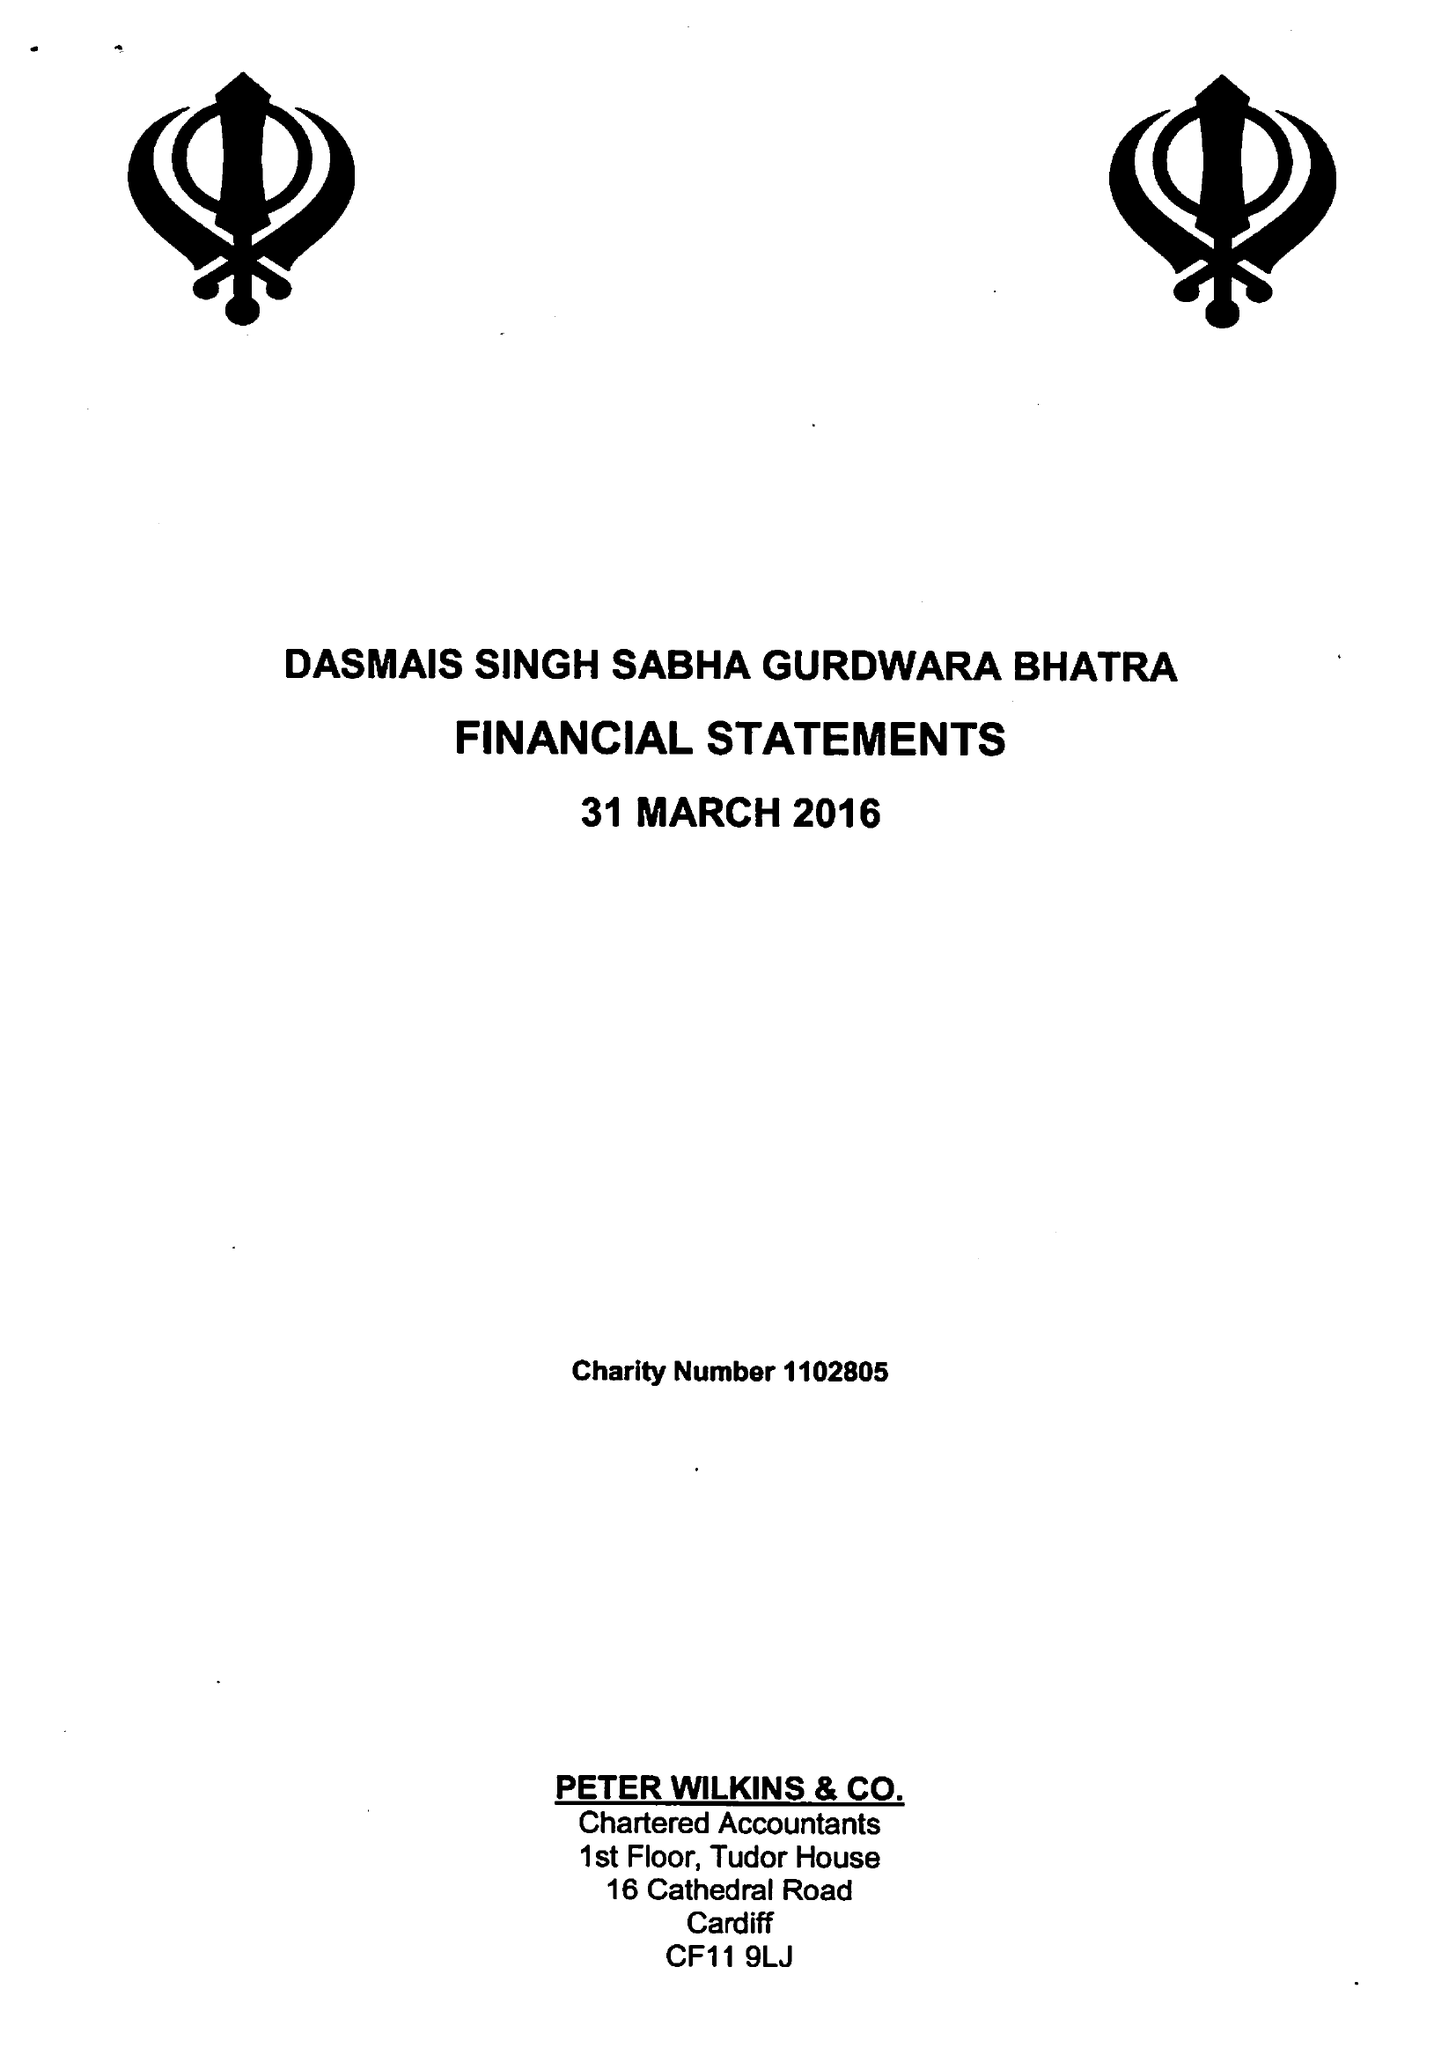What is the value for the income_annually_in_british_pounds?
Answer the question using a single word or phrase. 52503.00 